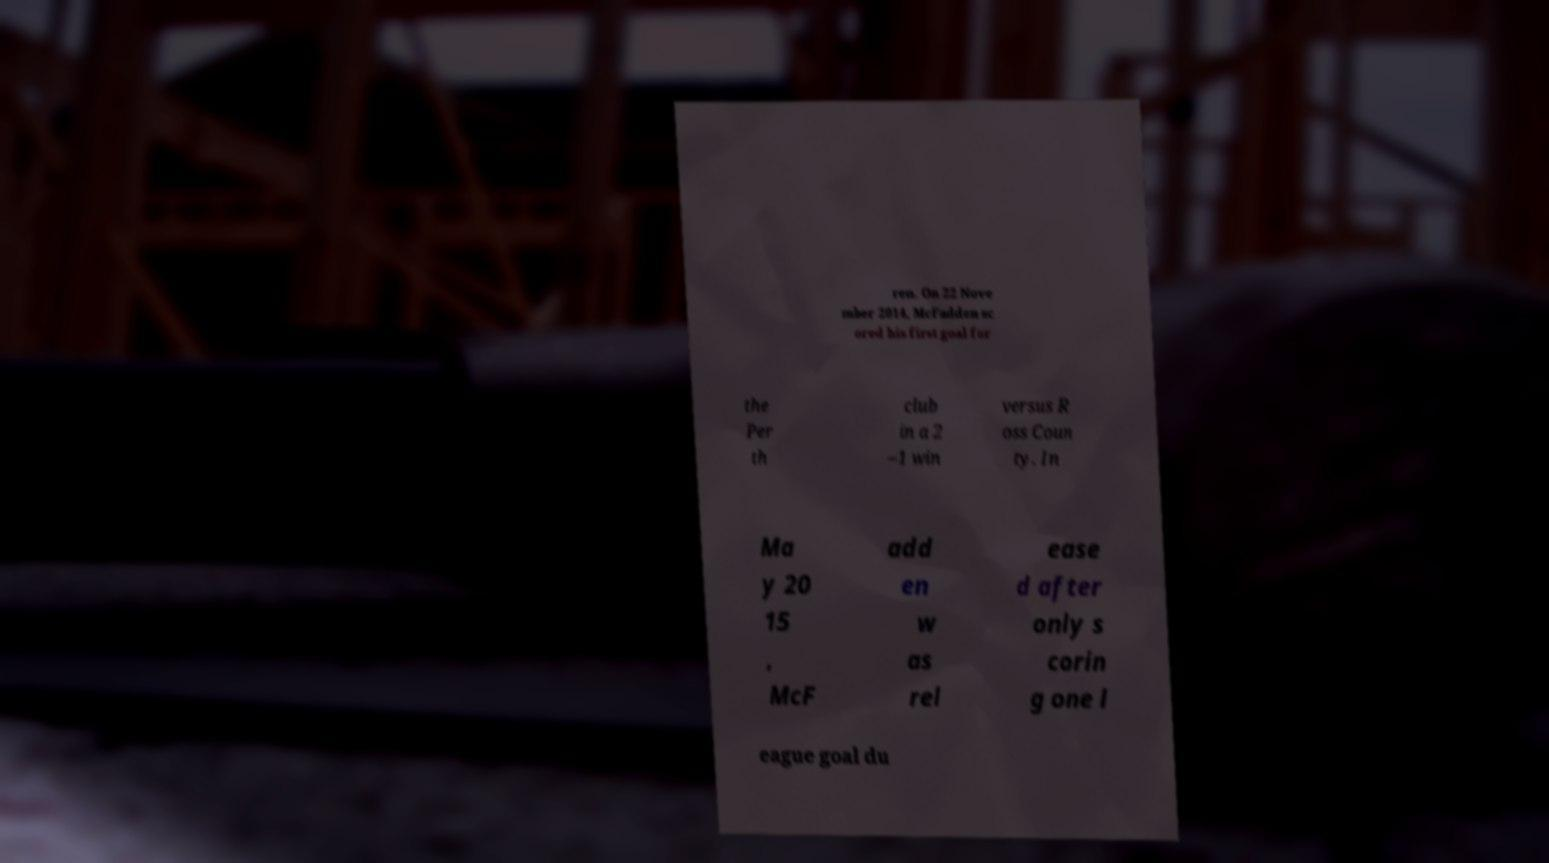Please read and relay the text visible in this image. What does it say? ren. On 22 Nove mber 2014, McFadden sc ored his first goal for the Per th club in a 2 –1 win versus R oss Coun ty. In Ma y 20 15 , McF add en w as rel ease d after only s corin g one l eague goal du 